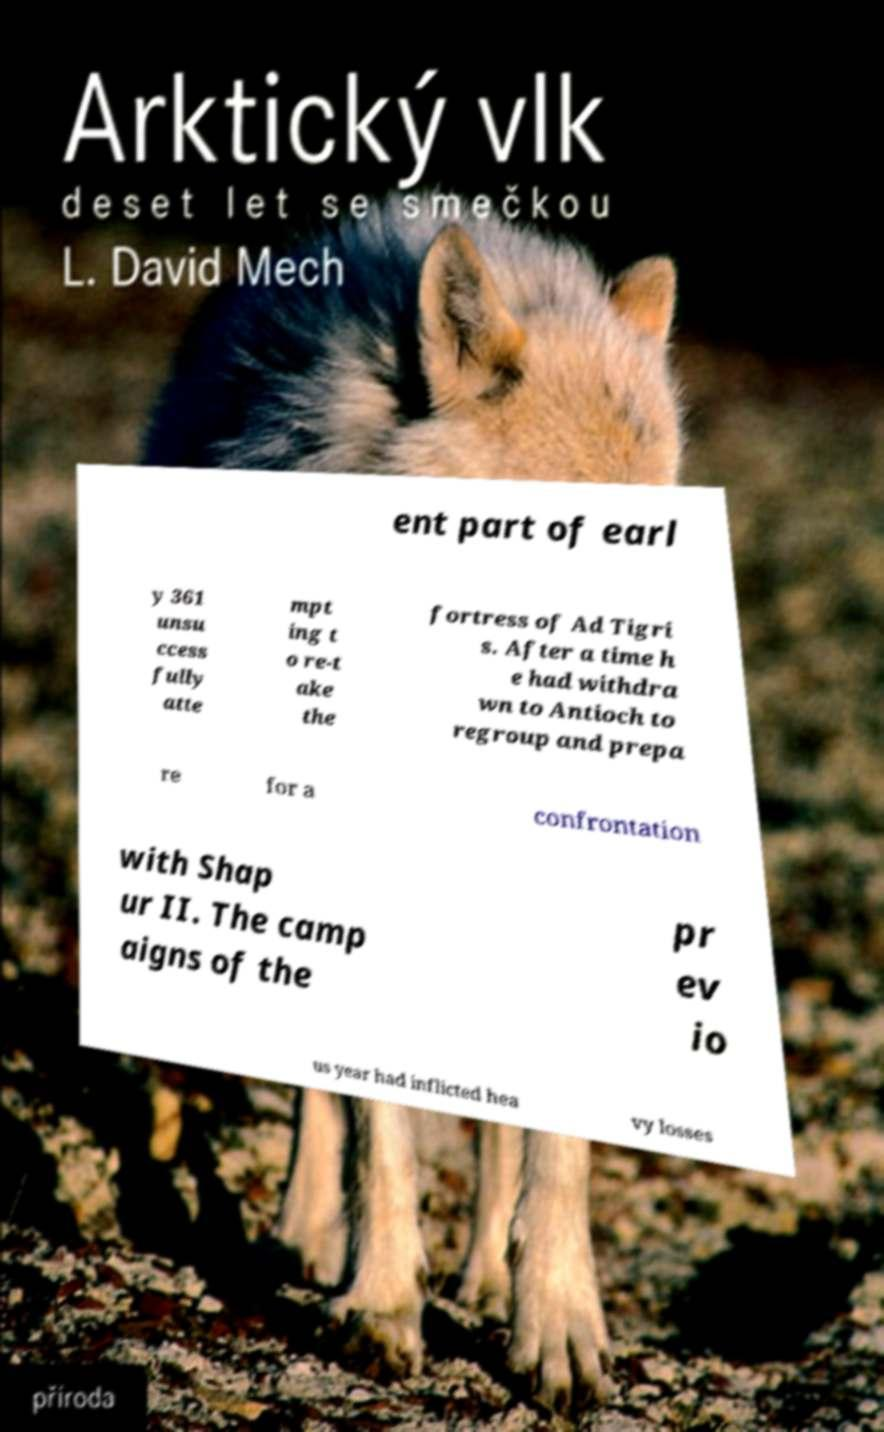Could you assist in decoding the text presented in this image and type it out clearly? ent part of earl y 361 unsu ccess fully atte mpt ing t o re-t ake the fortress of Ad Tigri s. After a time h e had withdra wn to Antioch to regroup and prepa re for a confrontation with Shap ur II. The camp aigns of the pr ev io us year had inflicted hea vy losses 